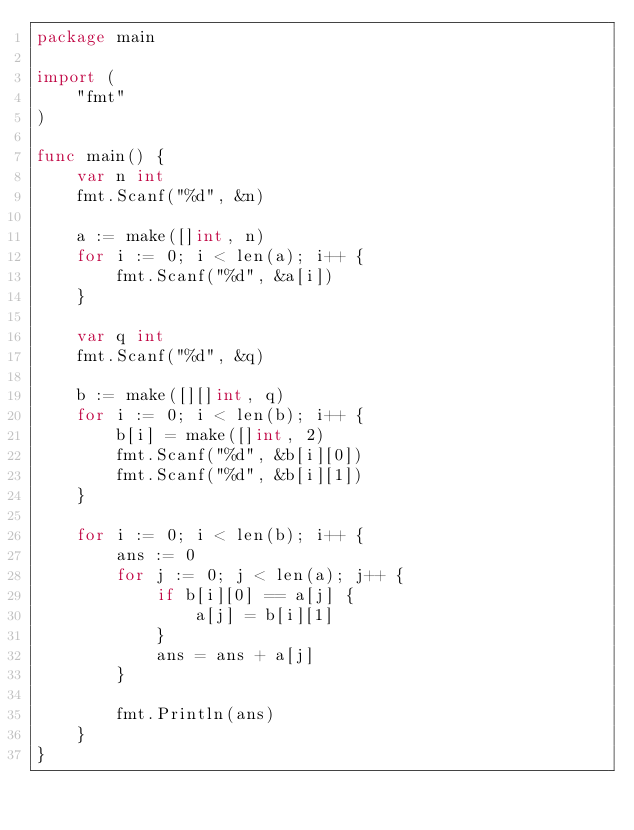Convert code to text. <code><loc_0><loc_0><loc_500><loc_500><_Go_>package main

import (
	"fmt"
)

func main() {
	var n int
	fmt.Scanf("%d", &n)

	a := make([]int, n)
	for i := 0; i < len(a); i++ {
		fmt.Scanf("%d", &a[i])
	}

	var q int
	fmt.Scanf("%d", &q)

	b := make([][]int, q)
	for i := 0; i < len(b); i++ {
		b[i] = make([]int, 2)
		fmt.Scanf("%d", &b[i][0])
		fmt.Scanf("%d", &b[i][1])
	}

	for i := 0; i < len(b); i++ {
		ans := 0
		for j := 0; j < len(a); j++ {
			if b[i][0] == a[j] {
				a[j] = b[i][1]
			}
			ans = ans + a[j]
		}

		fmt.Println(ans)
	}
}
</code> 